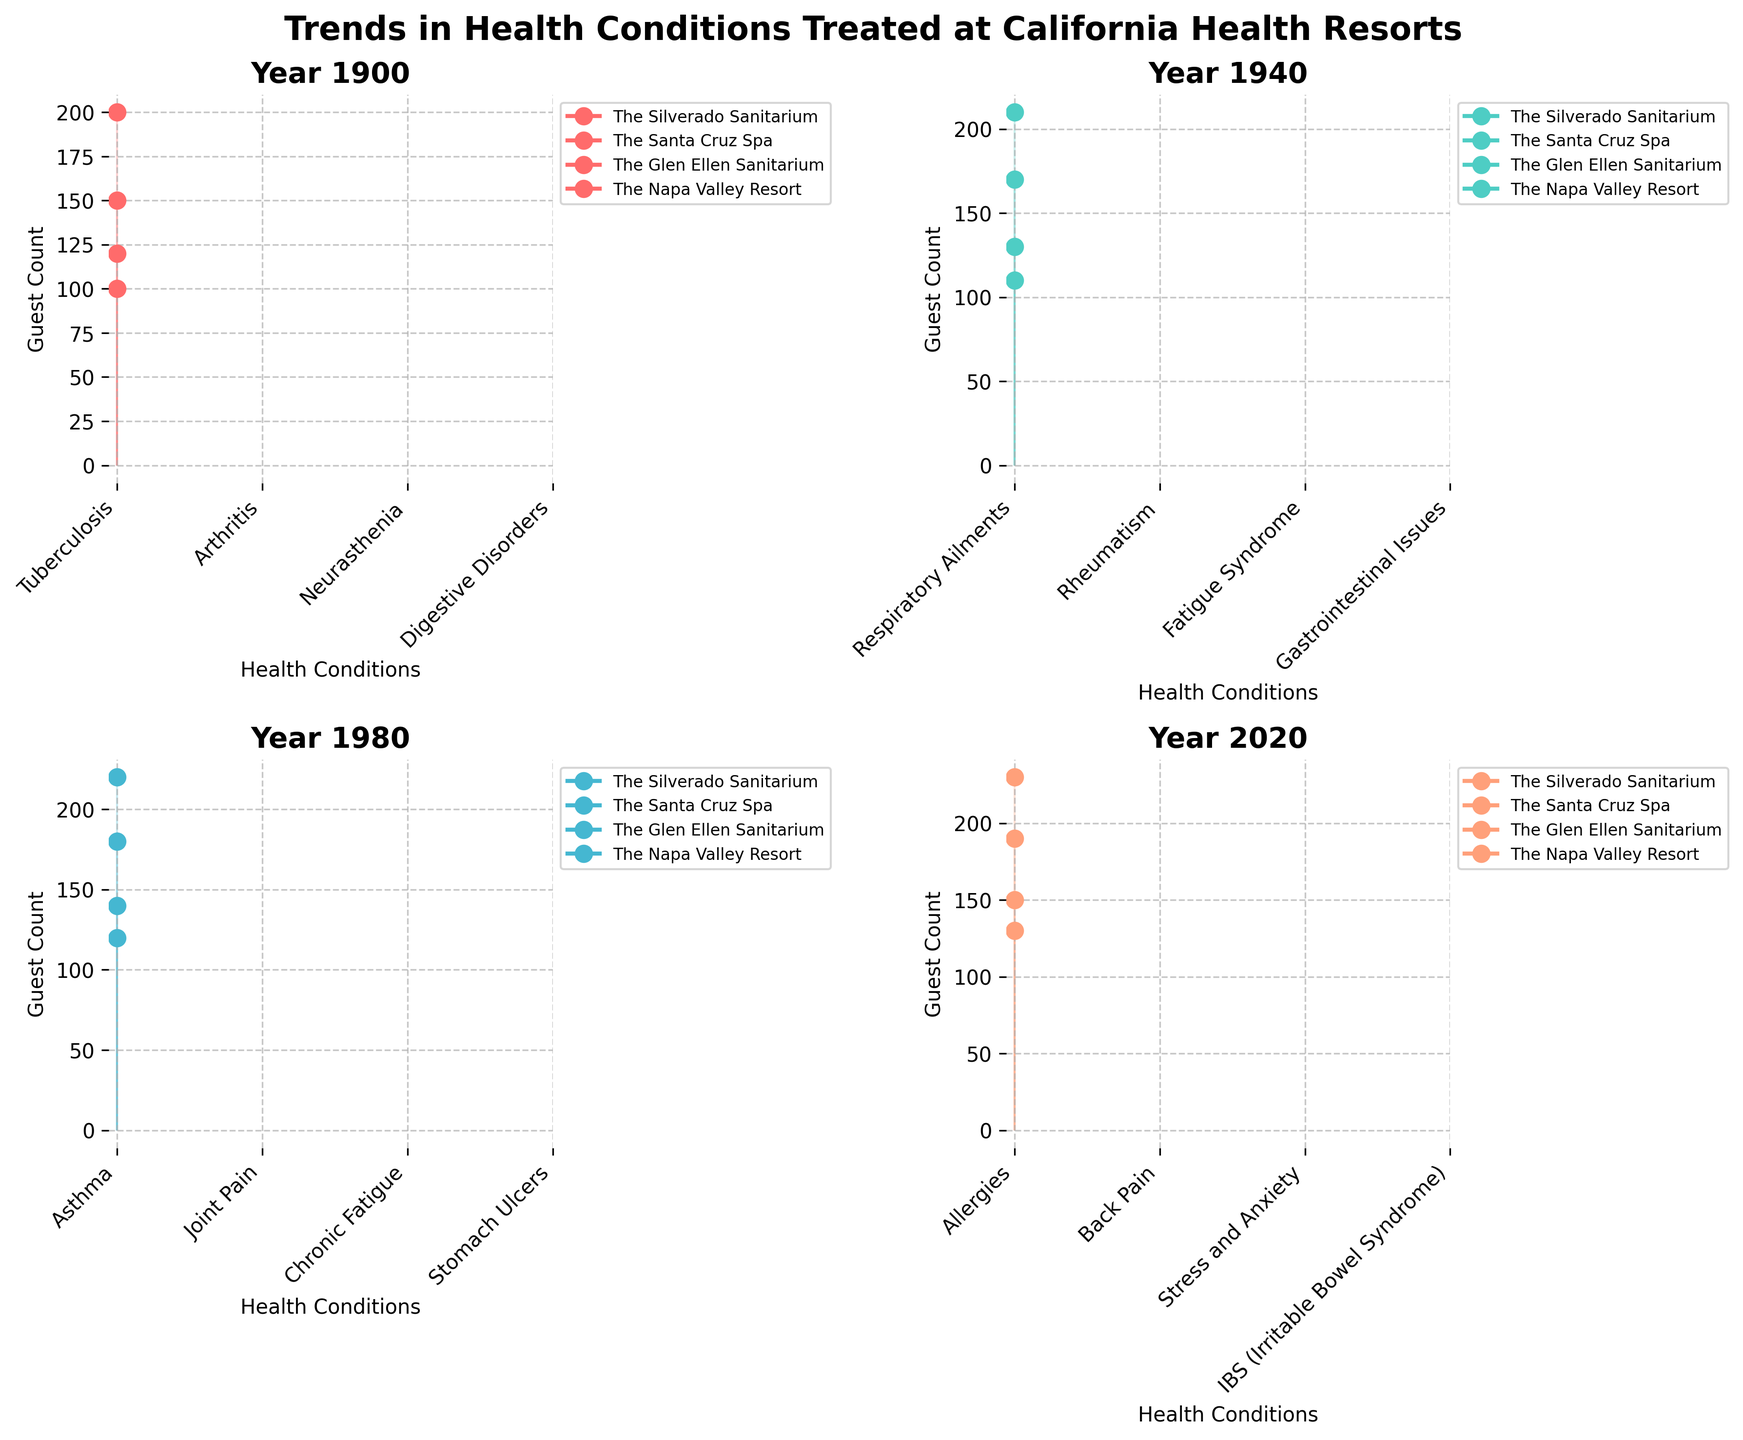What is the title of the figure? The title is displayed at the top of the figure in bold text.
Answer: Trends in Health Conditions Treated at California Health Resorts What are the four years highlighted in the subplot? Each subplot has a title that indicates the specific year featured.
Answer: 1900, 1940, 1980, 2020 In which year does The Glen Ellen Sanitarium have the highest guest count? By examining the plots for each year, one should look for the highest peak in guest count for The Glen Ellen Sanitarium.
Answer: 2020 In 1940, which health resort had the highest guest count for its treated condition? Observe the peak values for each health resort in the subplot for the year 1940.
Answer: The Glen Ellen Sanitarium How does the number of health conditions treated by each resort change over the years? Count the health conditions listed on the x-axis for each resort in their respective plots.
Answer: They remain constant (each treats one condition) Which health resort treated the highest number of guests in 1980? Check the plot for 1980 and compare the highest points for each resort.
Answer: The Glen Ellen Sanitarium Compare the guest count for The Napa Valley Resort between 1940 and 2020. Look at the plots for those years and note the y-values for The Napa Valley Resort.
Answer: 110 guests in 1940 and 130 guests in 2020 How did the guest count for The Silverado Sanitarium change from 1900 to 2020? Find the guest count values in the 1900 and 2020 plots.
Answer: Increased from 150 to 190 Which year shows the highest overall guest count across all resorts? Sum the guest counts for all resorts in each subplot and compare.
Answer: 2020 